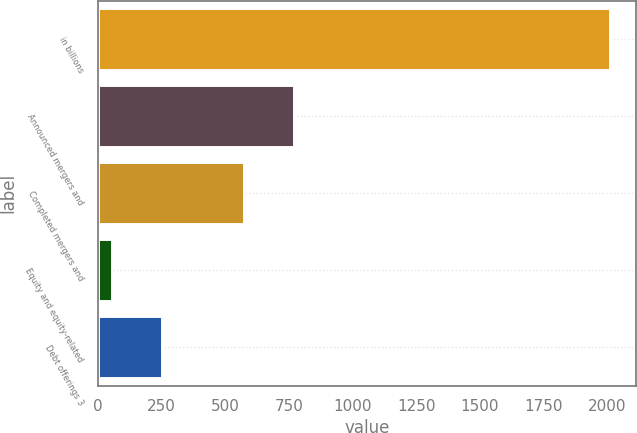Convert chart. <chart><loc_0><loc_0><loc_500><loc_500><bar_chart><fcel>in billions<fcel>Announced mergers and<fcel>Completed mergers and<fcel>Equity and equity-related<fcel>Debt offerings 3<nl><fcel>2012<fcel>769.5<fcel>574<fcel>57<fcel>252.5<nl></chart> 